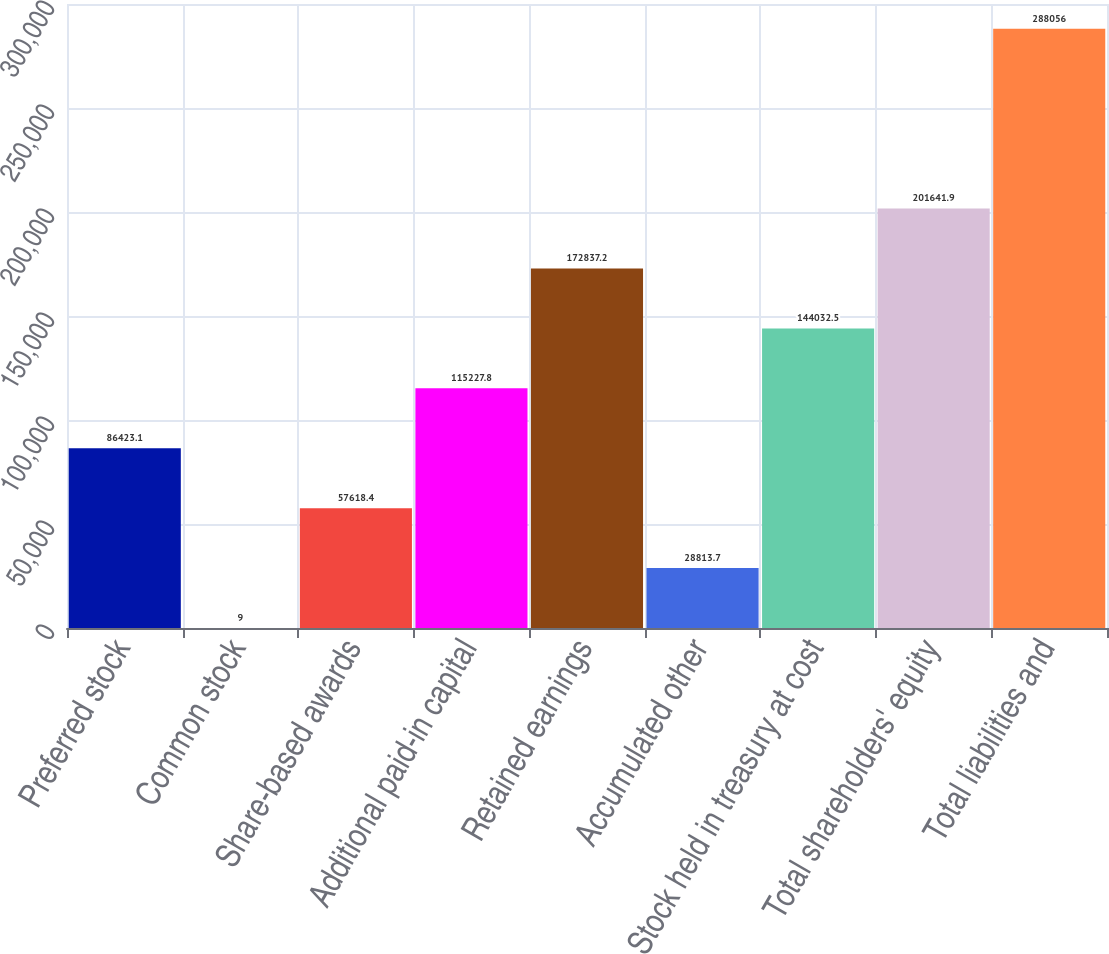Convert chart to OTSL. <chart><loc_0><loc_0><loc_500><loc_500><bar_chart><fcel>Preferred stock<fcel>Common stock<fcel>Share-based awards<fcel>Additional paid-in capital<fcel>Retained earnings<fcel>Accumulated other<fcel>Stock held in treasury at cost<fcel>Total shareholders' equity<fcel>Total liabilities and<nl><fcel>86423.1<fcel>9<fcel>57618.4<fcel>115228<fcel>172837<fcel>28813.7<fcel>144032<fcel>201642<fcel>288056<nl></chart> 